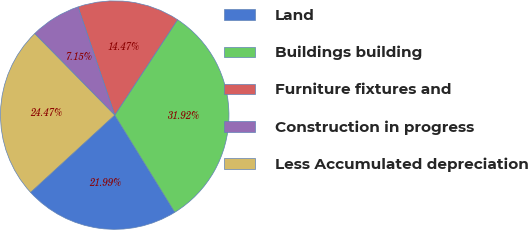Convert chart to OTSL. <chart><loc_0><loc_0><loc_500><loc_500><pie_chart><fcel>Land<fcel>Buildings building<fcel>Furniture fixtures and<fcel>Construction in progress<fcel>Less Accumulated depreciation<nl><fcel>21.99%<fcel>31.92%<fcel>14.47%<fcel>7.15%<fcel>24.47%<nl></chart> 